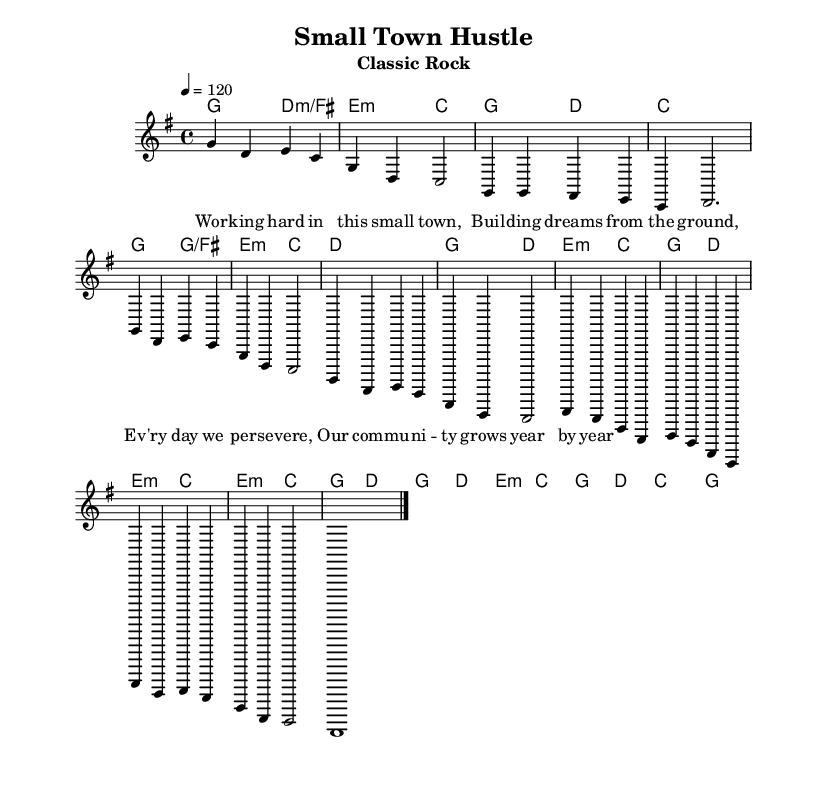What is the key signature of this music? The key signature is G major, which has one sharp (F#).
Answer: G major What is the time signature of this music? The time signature is 4/4, indicating four beats per measure with a quarter note receiving one beat.
Answer: 4/4 What is the tempo marking for this piece? The tempo marking indicates a speed of 120 beats per minute, which can be observed in the score's tempo notation.
Answer: 120 How many measures are in the verse section? The verse section, as highlighted in the melody, consists of four measures, counting from the start of the verse.
Answer: 4 What chords are used in the chorus? The chords used in the chorus include G and D, as indicated by the chord changes aligned with the melody for that section.
Answer: G, D What is the theme captured in the lyrics of this song? The theme revolves around hard work and community perseverance, directly reflecting in the lyrics provided for the melody.
Answer: Hard work and community How does the bridge transition musically from the verse? The bridge transitions musically from the verse by changing the chord progression to include E minor and introducing a new melodic texture, creating contrast.
Answer: E minor and new texture 